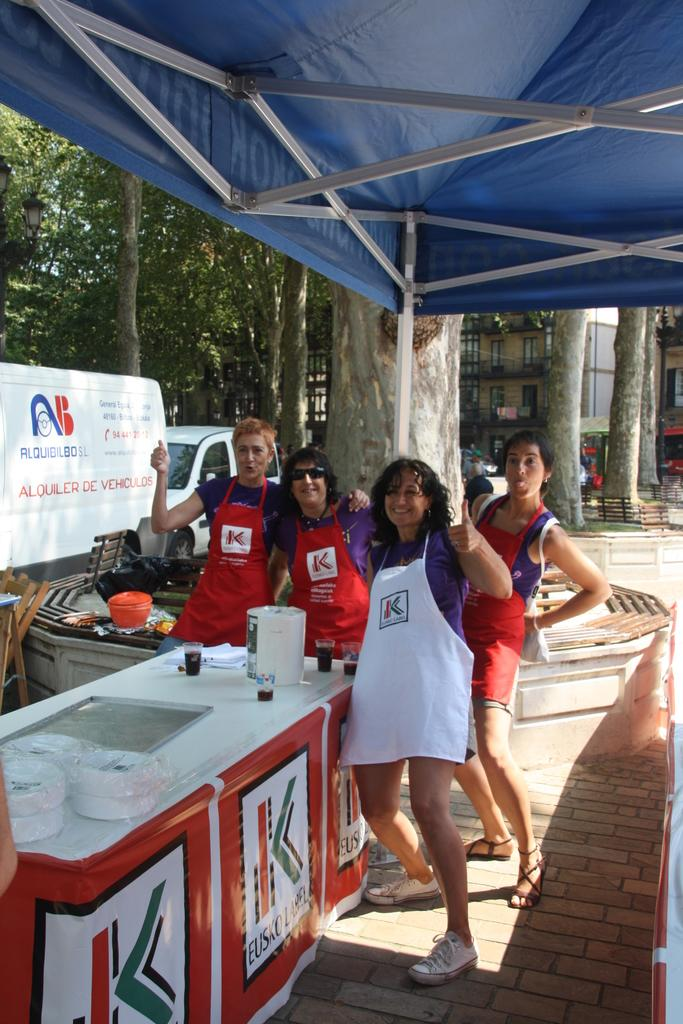<image>
Summarize the visual content of the image. Four people posing for the camera wearing aprons emblazoned with the letter K. 